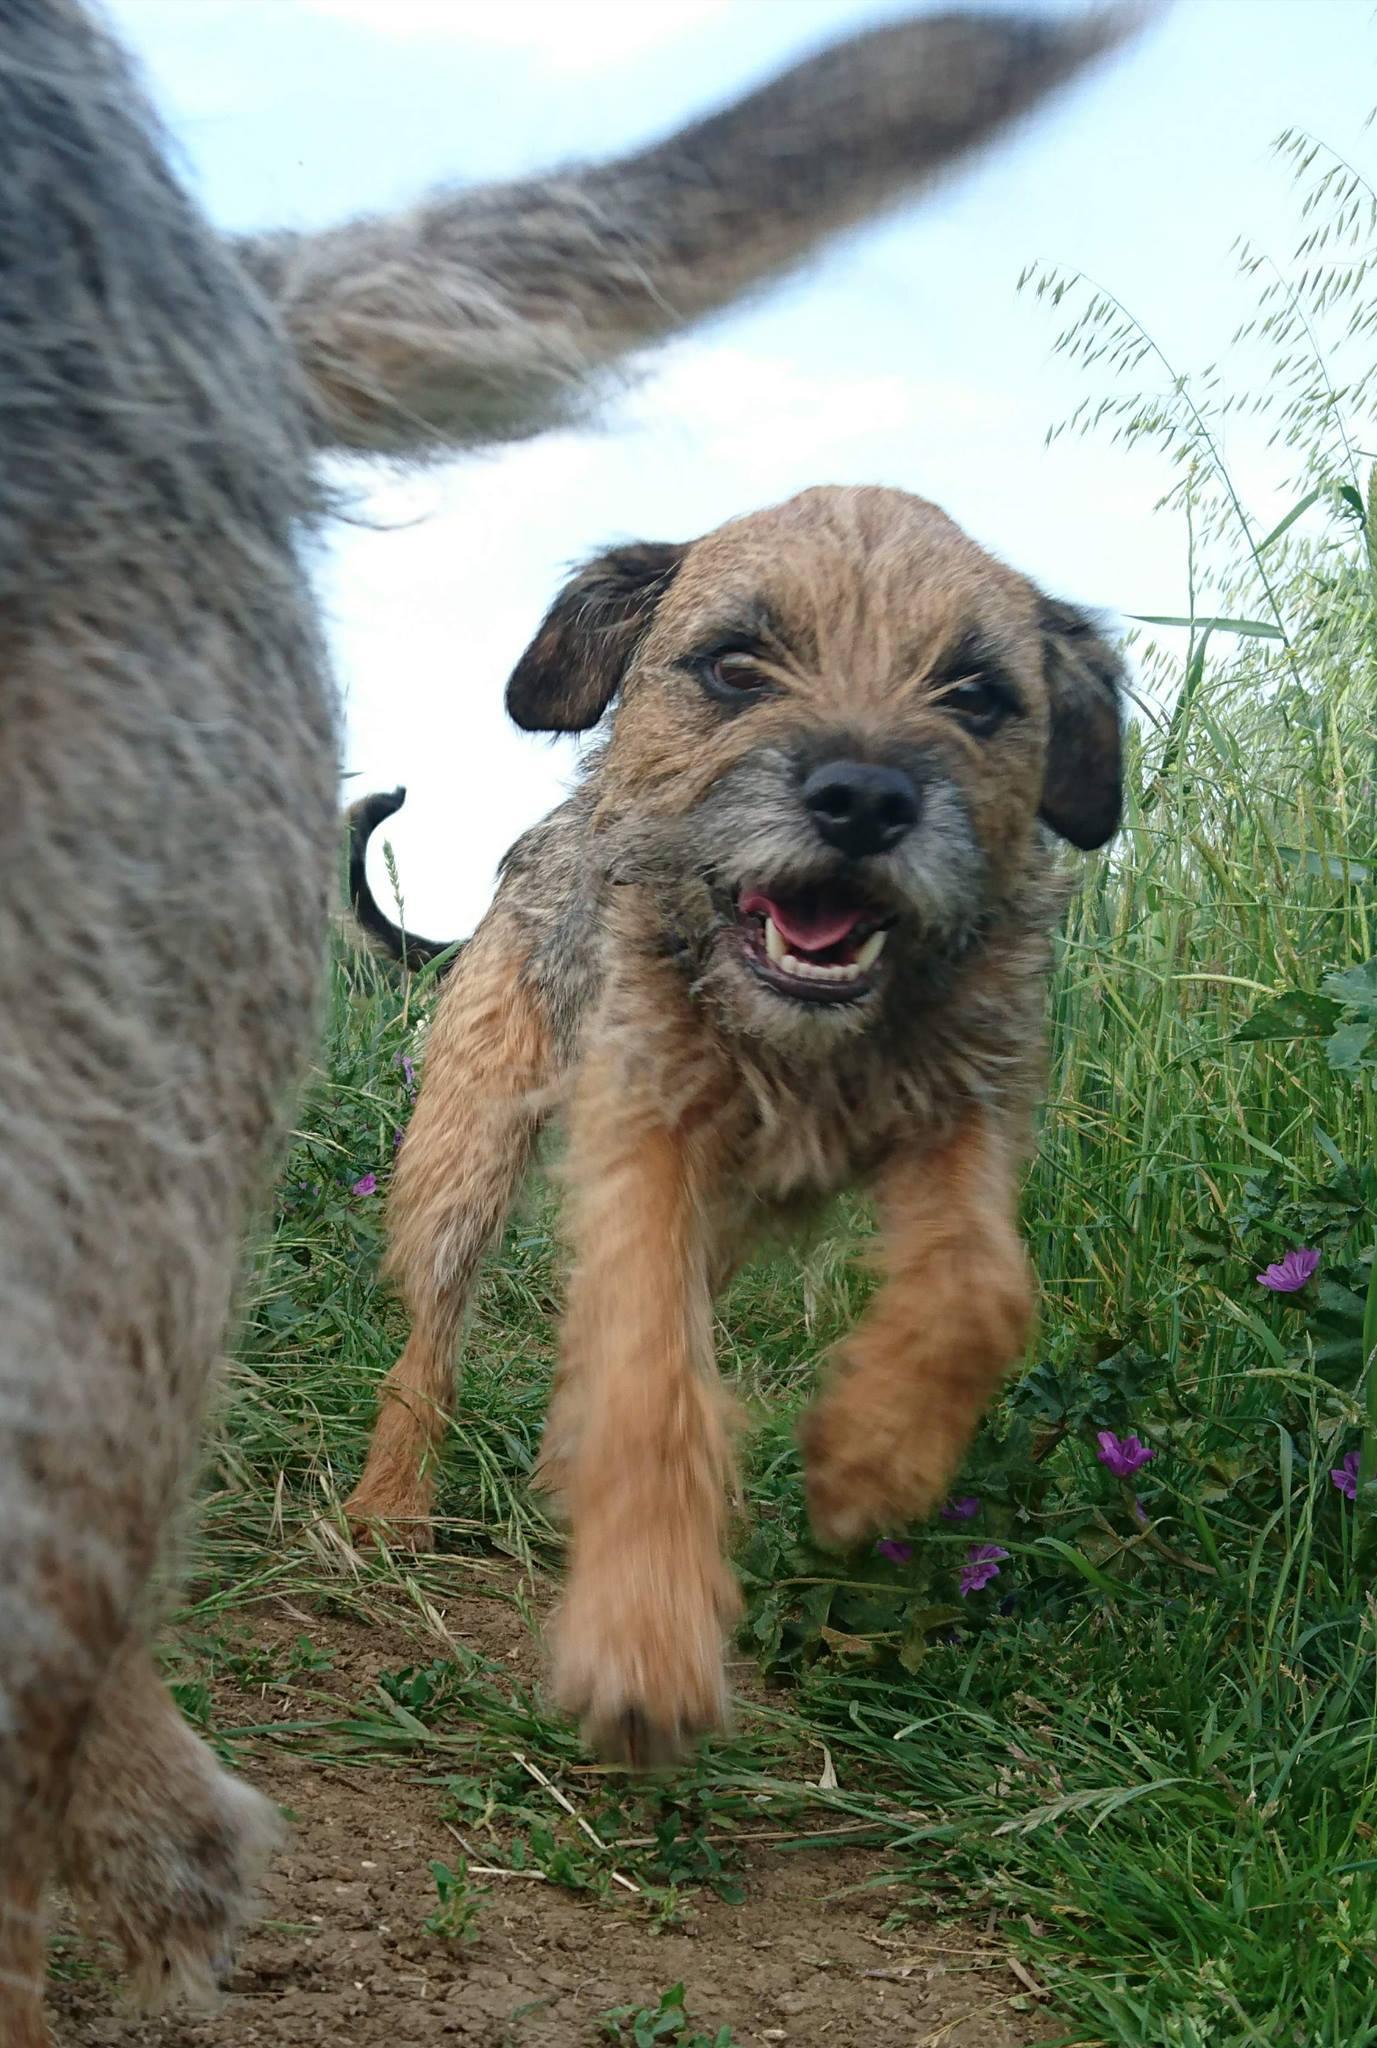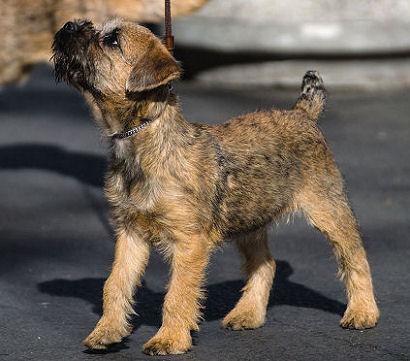The first image is the image on the left, the second image is the image on the right. Given the left and right images, does the statement "In at least one image there is a single dog sitting facing right forward." hold true? Answer yes or no. No. The first image is the image on the left, the second image is the image on the right. Considering the images on both sides, is "The puppy on the left is running, while the one on the right is not." valid? Answer yes or no. Yes. 